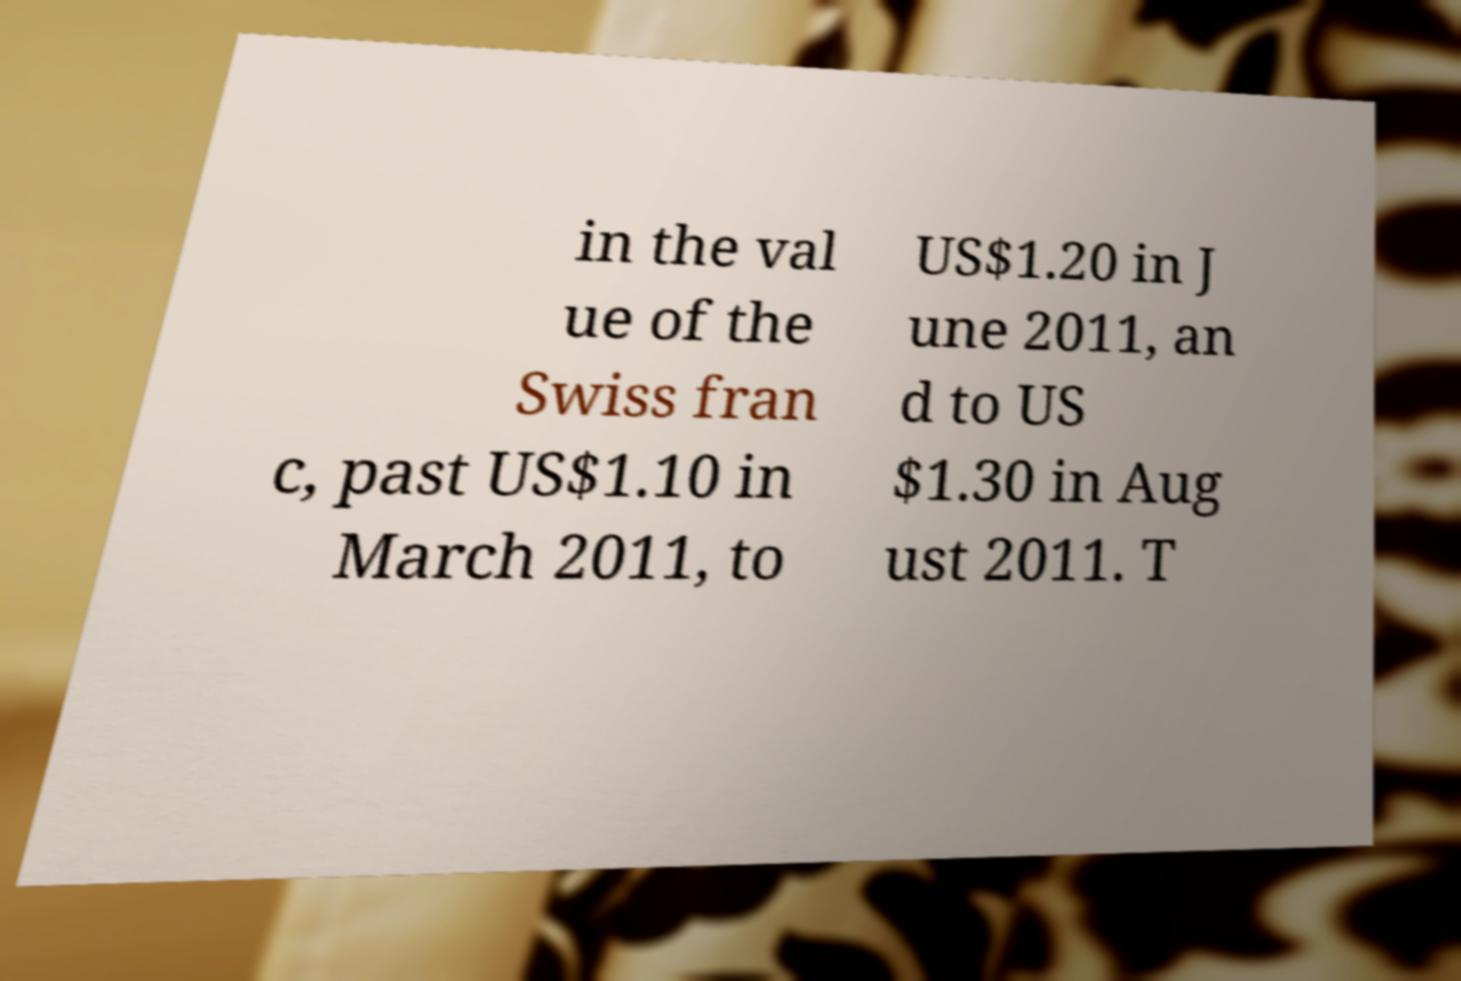Please identify and transcribe the text found in this image. in the val ue of the Swiss fran c, past US$1.10 in March 2011, to US$1.20 in J une 2011, an d to US $1.30 in Aug ust 2011. T 